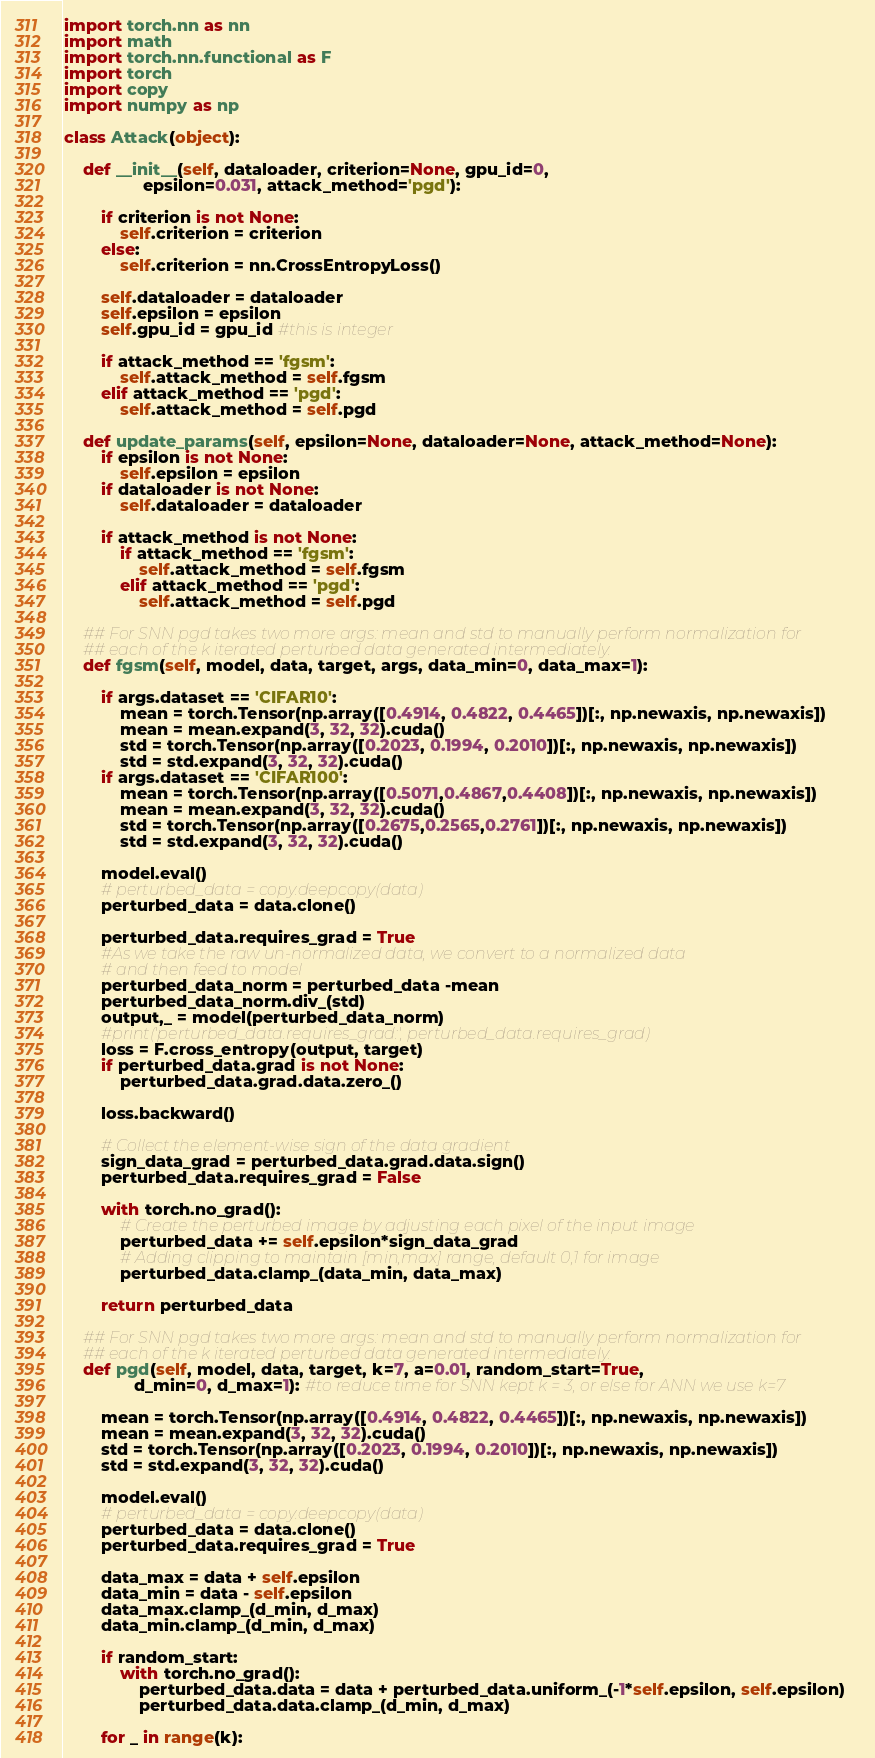Convert code to text. <code><loc_0><loc_0><loc_500><loc_500><_Python_>import torch.nn as nn
import math
import torch.nn.functional as F
import torch
import copy
import numpy as np

class Attack(object):

    def __init__(self, dataloader, criterion=None, gpu_id=0, 
                 epsilon=0.031, attack_method='pgd'):
        
        if criterion is not None:
            self.criterion = criterion
        else:
            self.criterion = nn.CrossEntropyLoss()
            
        self.dataloader = dataloader
        self.epsilon = epsilon
        self.gpu_id = gpu_id #this is integer

        if attack_method == 'fgsm':
            self.attack_method = self.fgsm
        elif attack_method == 'pgd':
            self.attack_method = self.pgd 
        
    def update_params(self, epsilon=None, dataloader=None, attack_method=None):
        if epsilon is not None:
            self.epsilon = epsilon
        if dataloader is not None:
            self.dataloader = dataloader
            
        if attack_method is not None:
            if attack_method == 'fgsm':
                self.attack_method = self.fgsm
            elif attack_method == 'pgd':
                self.attack_method = self.pgd

    ## For SNN pgd takes two more args: mean and std to manually perform normalization for 
    ## each of the k iterated perturbed data generated intermediately.                               
    def fgsm(self, model, data, target, args, data_min=0, data_max=1):
        
        if args.dataset == 'CIFAR10':
            mean = torch.Tensor(np.array([0.4914, 0.4822, 0.4465])[:, np.newaxis, np.newaxis])
            mean = mean.expand(3, 32, 32).cuda()
            std = torch.Tensor(np.array([0.2023, 0.1994, 0.2010])[:, np.newaxis, np.newaxis])
            std = std.expand(3, 32, 32).cuda()
        if args.dataset == 'CIFAR100':
            mean = torch.Tensor(np.array([0.5071,0.4867,0.4408])[:, np.newaxis, np.newaxis])
            mean = mean.expand(3, 32, 32).cuda()
            std = torch.Tensor(np.array([0.2675,0.2565,0.2761])[:, np.newaxis, np.newaxis])
            std = std.expand(3, 32, 32).cuda()

        model.eval()
        # perturbed_data = copy.deepcopy(data)
        perturbed_data = data.clone()
        
        perturbed_data.requires_grad = True
        #As we take the raw un-normalized data, we convert to a normalized data
        # and then feed to model
        perturbed_data_norm = perturbed_data -mean
        perturbed_data_norm.div_(std)
        output,_ = model(perturbed_data_norm)
        #print('perturbed_data.requires_grad:', perturbed_data.requires_grad) 
        loss = F.cross_entropy(output, target)
        if perturbed_data.grad is not None:
            perturbed_data.grad.data.zero_()

        loss.backward()
        
        # Collect the element-wise sign of the data gradient
        sign_data_grad = perturbed_data.grad.data.sign()
        perturbed_data.requires_grad = False

        with torch.no_grad():
            # Create the perturbed image by adjusting each pixel of the input image
            perturbed_data += self.epsilon*sign_data_grad
            # Adding clipping to maintain [min,max] range, default 0,1 for image
            perturbed_data.clamp_(data_min, data_max)
    
        return perturbed_data
        
    ## For SNN pgd takes two more args: mean and std to manually perform normalization for 
    ## each of the k iterated perturbed data generated intermediately.
    def pgd(self, model, data, target, k=7, a=0.01, random_start=True,
               d_min=0, d_max=1): #to reduce time for SNN kept k = 3, or else for ANN we use k=7 
        
        mean = torch.Tensor(np.array([0.4914, 0.4822, 0.4465])[:, np.newaxis, np.newaxis])
        mean = mean.expand(3, 32, 32).cuda()
        std = torch.Tensor(np.array([0.2023, 0.1994, 0.2010])[:, np.newaxis, np.newaxis])
        std = std.expand(3, 32, 32).cuda()

        model.eval()
        # perturbed_data = copy.deepcopy(data)
        perturbed_data = data.clone()                                     
        perturbed_data.requires_grad = True
        
        data_max = data + self.epsilon
        data_min = data - self.epsilon
        data_max.clamp_(d_min, d_max)
        data_min.clamp_(d_min, d_max)

        if random_start:
            with torch.no_grad():
                perturbed_data.data = data + perturbed_data.uniform_(-1*self.epsilon, self.epsilon)
                perturbed_data.data.clamp_(d_min, d_max)
        
        for _ in range(k):</code> 